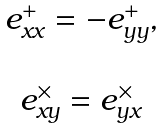<formula> <loc_0><loc_0><loc_500><loc_500>\begin{array} { c } e _ { x x } ^ { + } = - e _ { y y } ^ { + } , \\ \\ e _ { x y } ^ { \times } = e _ { y x } ^ { \times } \end{array}</formula> 